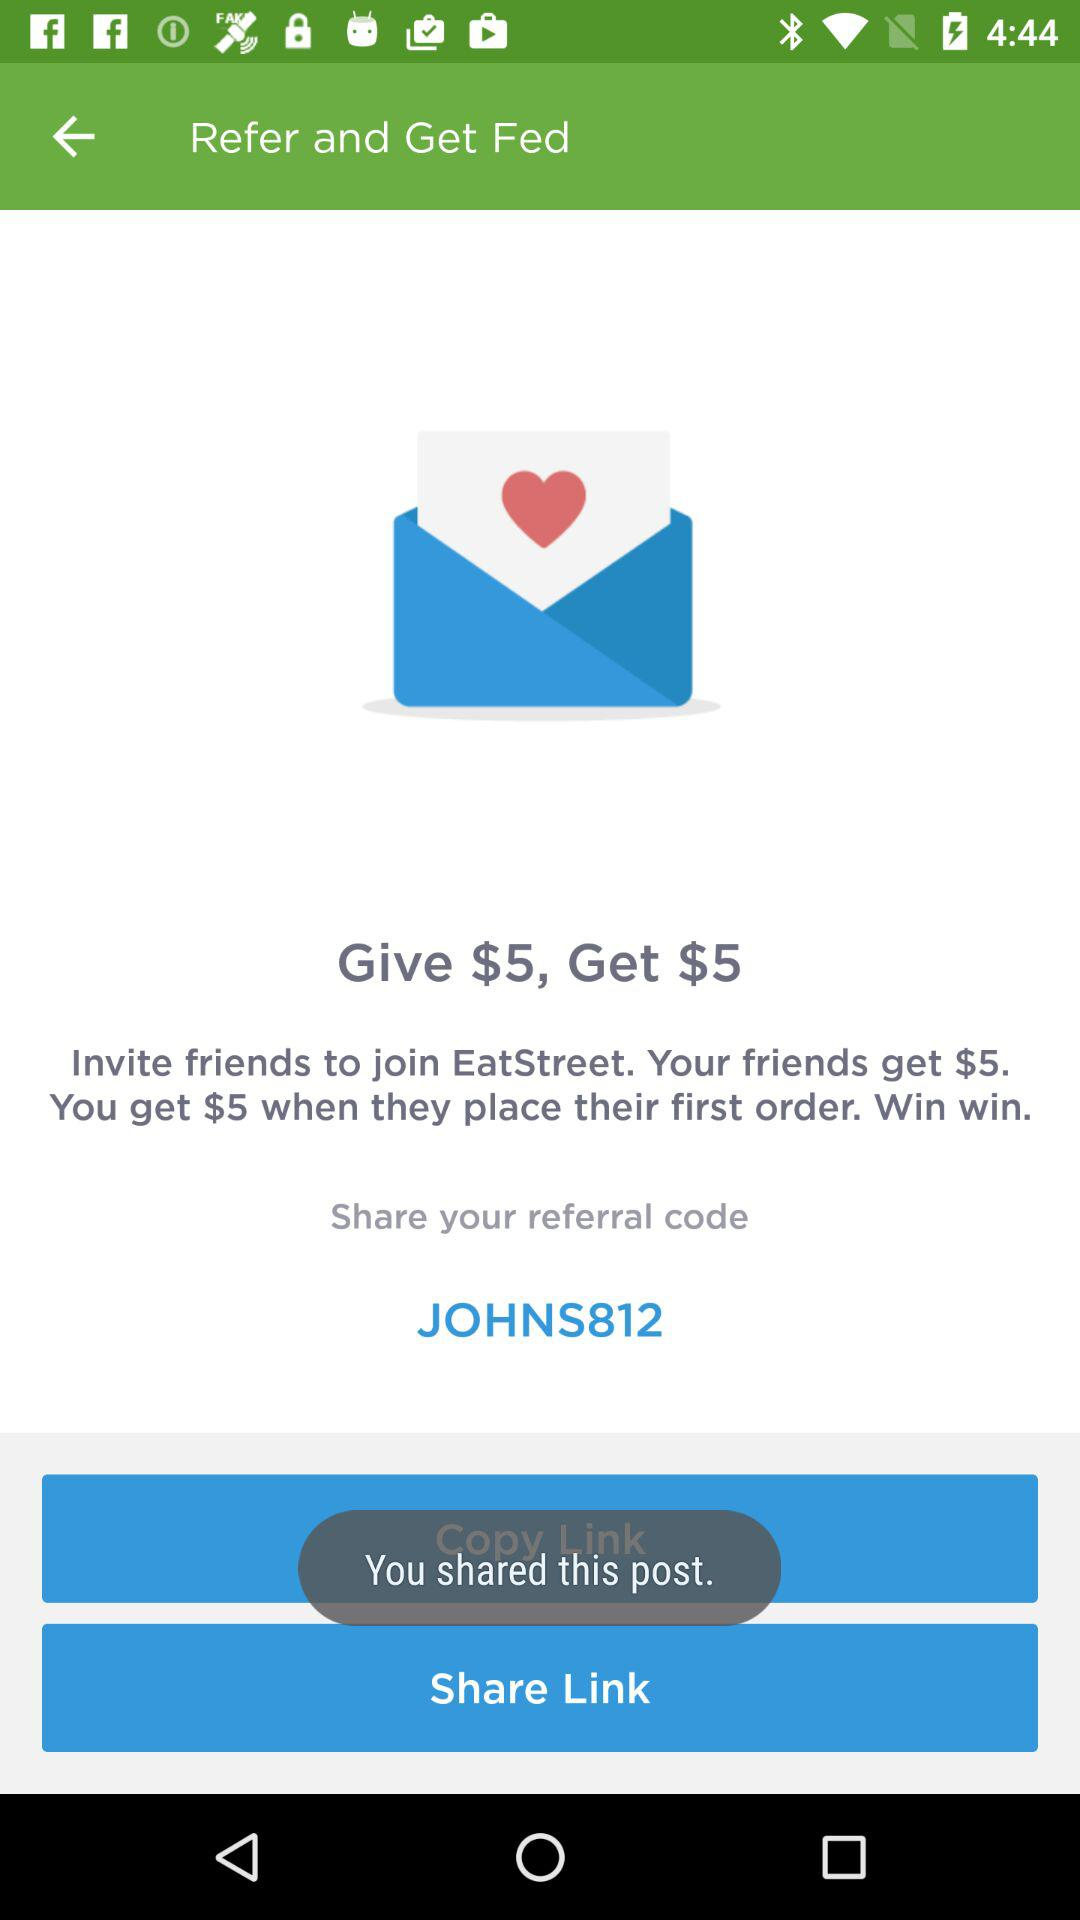What is the name of the application? The name of the application is "EatStreet". 